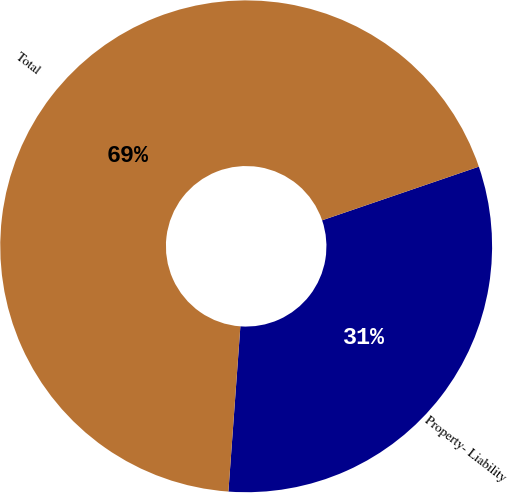Convert chart to OTSL. <chart><loc_0><loc_0><loc_500><loc_500><pie_chart><fcel>Property- Liability<fcel>Total<nl><fcel>31.4%<fcel>68.6%<nl></chart> 